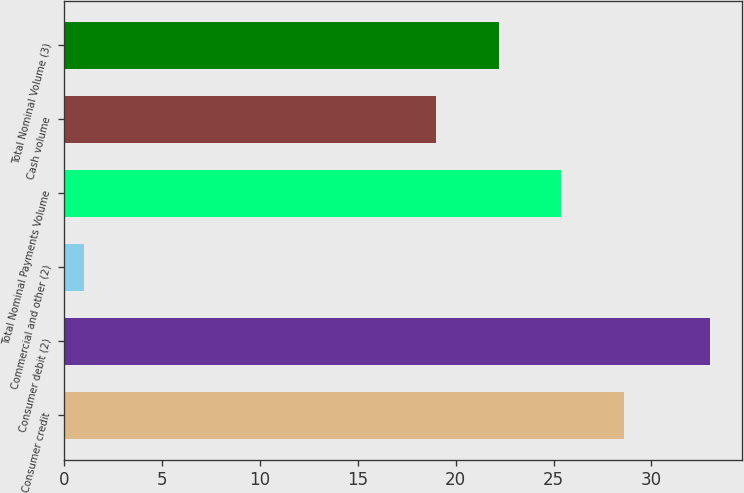Convert chart to OTSL. <chart><loc_0><loc_0><loc_500><loc_500><bar_chart><fcel>Consumer credit<fcel>Consumer debit (2)<fcel>Commercial and other (2)<fcel>Total Nominal Payments Volume<fcel>Cash volume<fcel>Total Nominal Volume (3)<nl><fcel>28.6<fcel>33<fcel>1<fcel>25.4<fcel>19<fcel>22.2<nl></chart> 